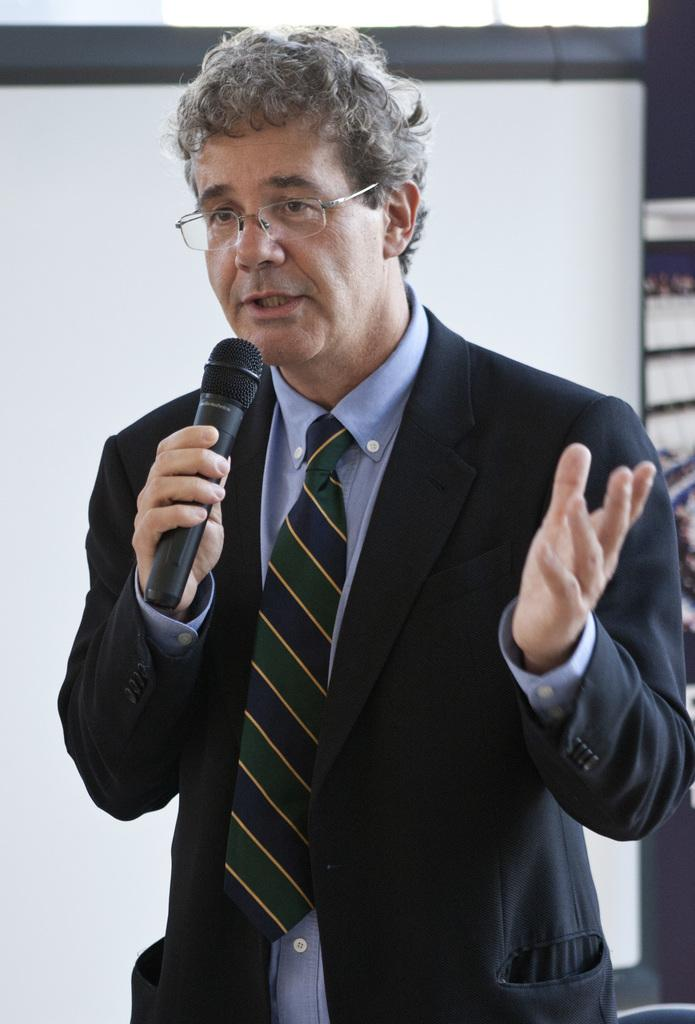Who is the main subject in the image? There is a man in the image. What is the man wearing on his face? The man is wearing spectacles. What type of clothing is the man wearing on his upper body? The man is wearing a blazer. What type of accessory is the man wearing around his neck? The man is wearing a tie. What object is the man holding in his hand? The man is holding a microphone in his hand. What might the man be doing based on the presence of the microphone? The man appears to be talking. How many chairs are visible in the image? There are no chairs visible in the image; it only features a man holding a microphone. What type of camera is the man using to take pictures in the image? There is no camera present in the image, and the man is not taking pictures. 